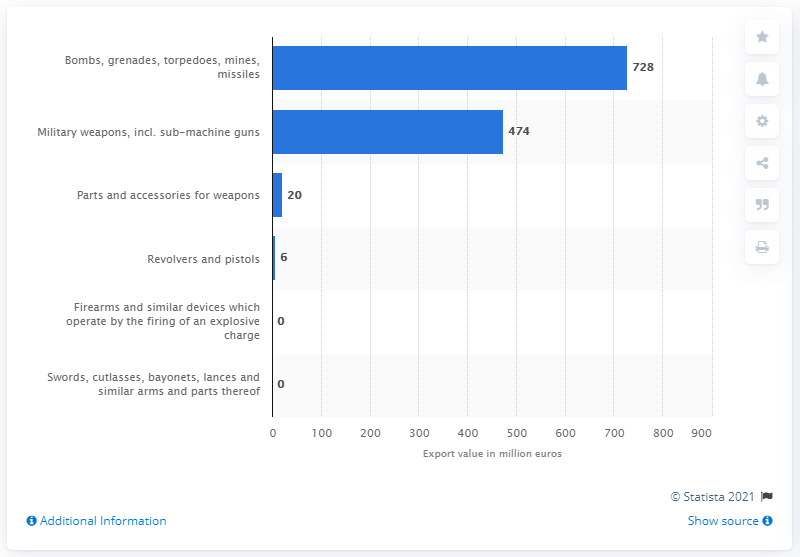Point out several critical features in this image. Romania exported 728 bombs, grenades, torpedoes, mines, and missiles in 2019. In 2019, the value of Romania's military weapons exports was 474. 